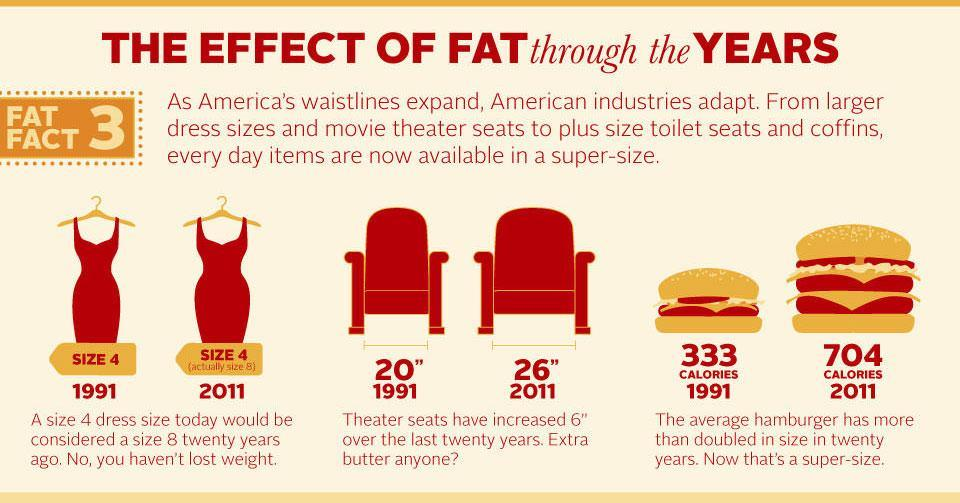In 2011, what is average hamburger calorie content?
Answer the question with a short phrase. 704 What is the theater seat size in 2011? 26" 